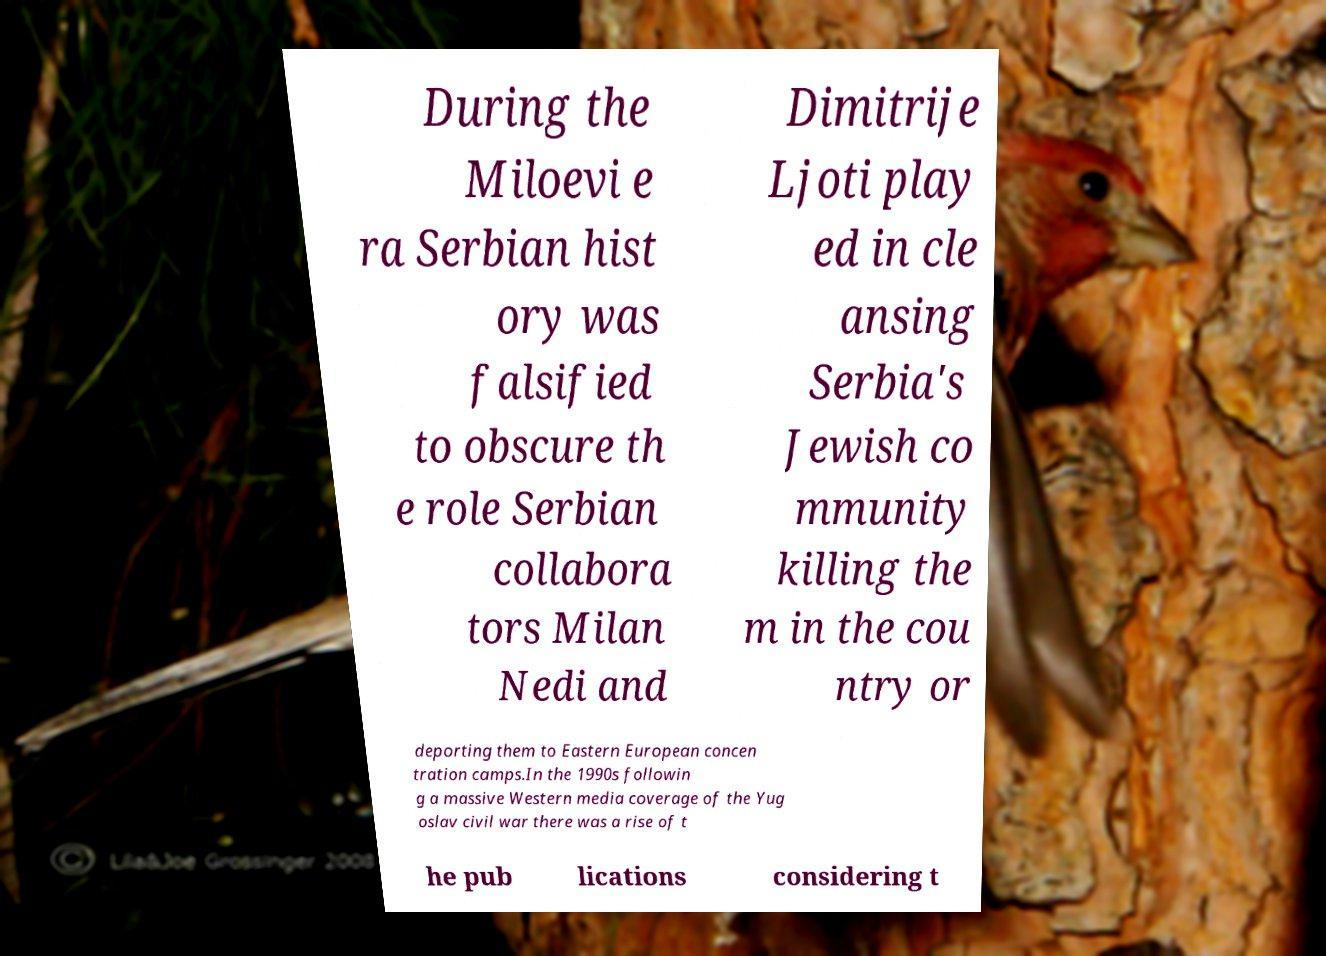What messages or text are displayed in this image? I need them in a readable, typed format. During the Miloevi e ra Serbian hist ory was falsified to obscure th e role Serbian collabora tors Milan Nedi and Dimitrije Ljoti play ed in cle ansing Serbia's Jewish co mmunity killing the m in the cou ntry or deporting them to Eastern European concen tration camps.In the 1990s followin g a massive Western media coverage of the Yug oslav civil war there was a rise of t he pub lications considering t 